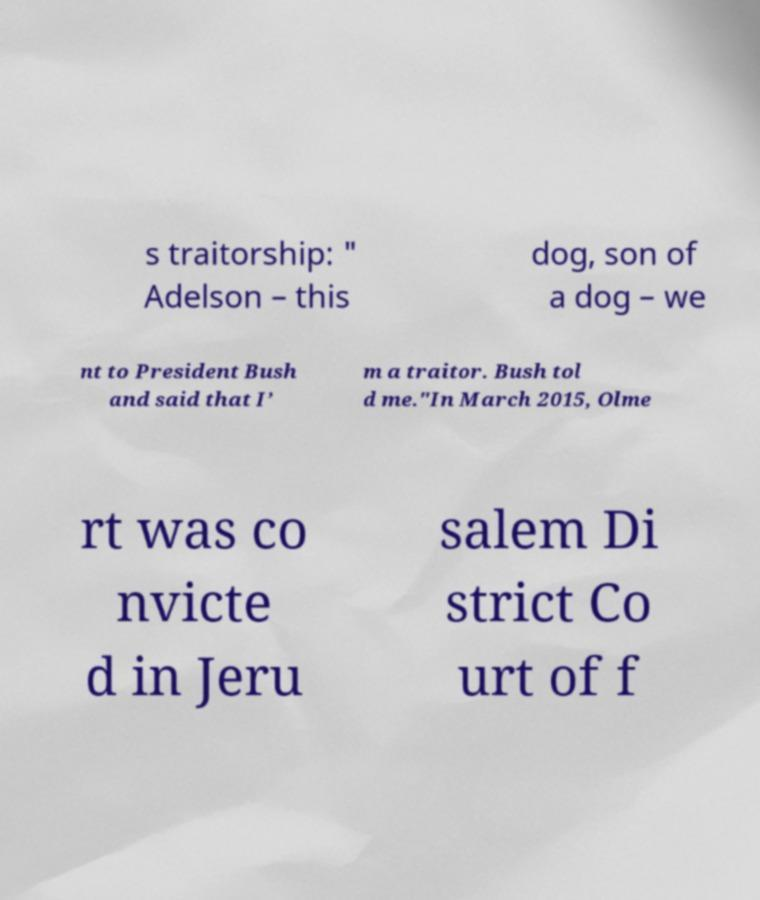There's text embedded in this image that I need extracted. Can you transcribe it verbatim? s traitorship: " Adelson – this dog, son of a dog – we nt to President Bush and said that I’ m a traitor. Bush tol d me."In March 2015, Olme rt was co nvicte d in Jeru salem Di strict Co urt of f 